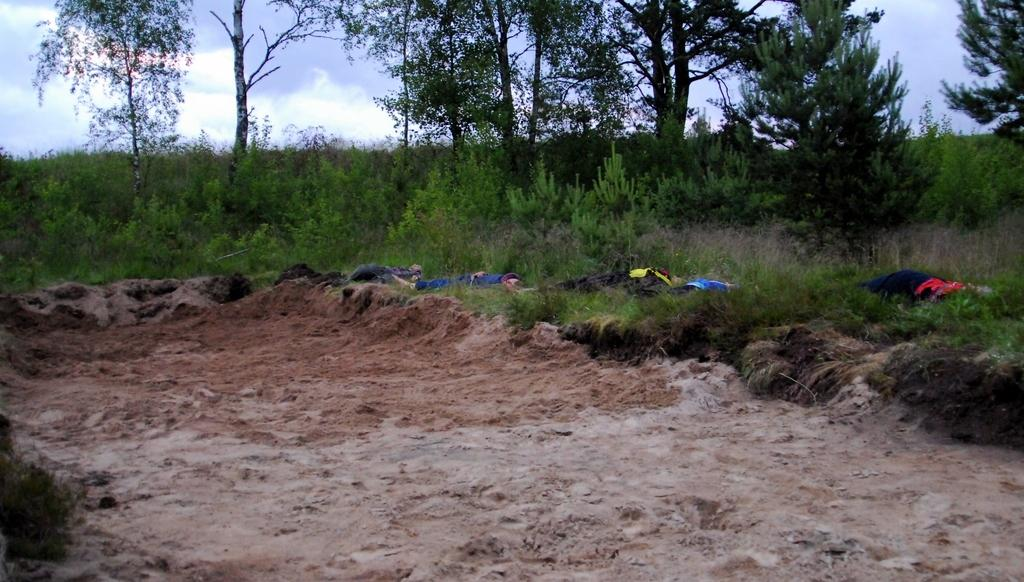What type of terrain is visible in the image? There is sand in the image. What can be seen on the grass in the image? There are objects on the grass. What type of vegetation is visible in the background of the image? There are plants and trees in the background of the image. What is visible in the sky in the image? The sky is visible in the background of the image. What type of calculator is being used by the visitor in the image? There is no visitor or calculator present in the image. 